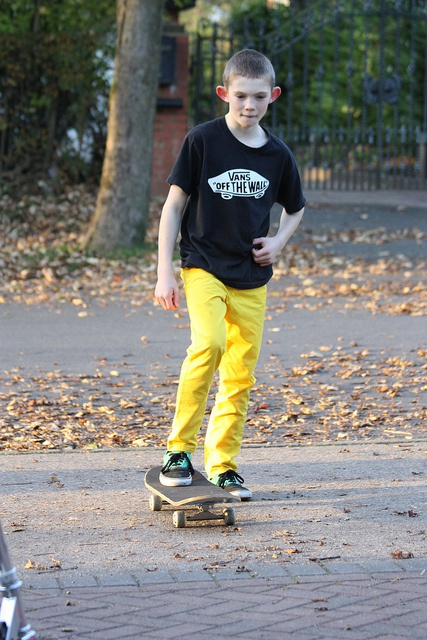Describe the objects in this image and their specific colors. I can see people in darkgreen, black, khaki, darkgray, and ivory tones and skateboard in darkgreen, gray, tan, and black tones in this image. 